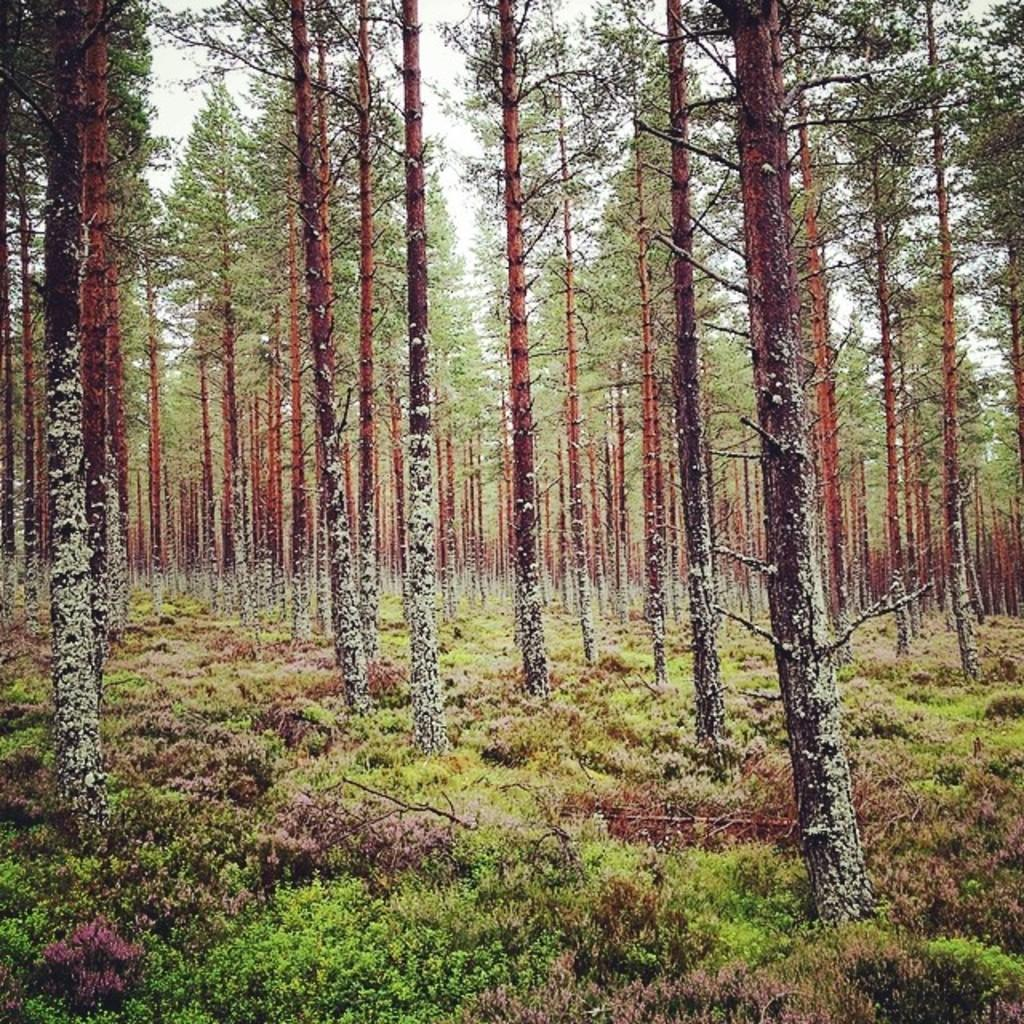What type of vegetation can be seen in the image? There are trees and small plants on the ground in the image. What can be seen in the background of the image? The sky is visible in the background of the image. Can you tell me how many errors the woman made in the image? There is no woman present in the image, and therefore no errors can be attributed to her. 